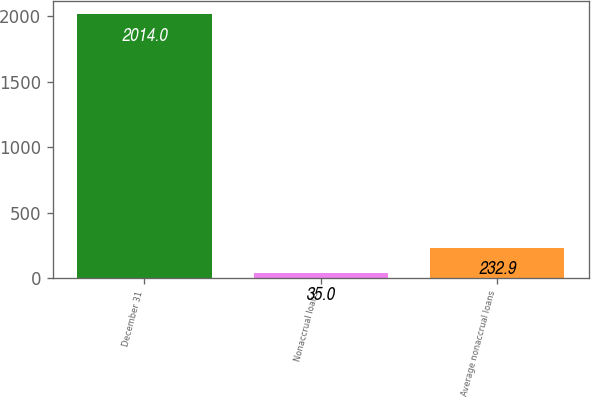Convert chart. <chart><loc_0><loc_0><loc_500><loc_500><bar_chart><fcel>December 31<fcel>Nonaccrual loans<fcel>Average nonaccrual loans<nl><fcel>2014<fcel>35<fcel>232.9<nl></chart> 